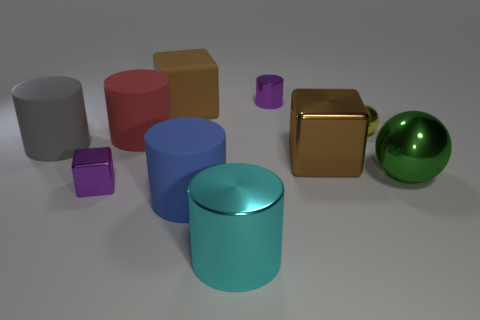Subtract all big brown shiny blocks. How many blocks are left? 2 Subtract all yellow spheres. How many spheres are left? 1 Subtract all cubes. How many objects are left? 7 Subtract 3 cubes. How many cubes are left? 0 Add 3 metallic cubes. How many metallic cubes are left? 5 Add 4 big gray cylinders. How many big gray cylinders exist? 5 Subtract 0 purple spheres. How many objects are left? 10 Subtract all green blocks. Subtract all green spheres. How many blocks are left? 3 Subtract all gray cylinders. How many purple cubes are left? 1 Subtract all big gray rubber spheres. Subtract all small yellow objects. How many objects are left? 9 